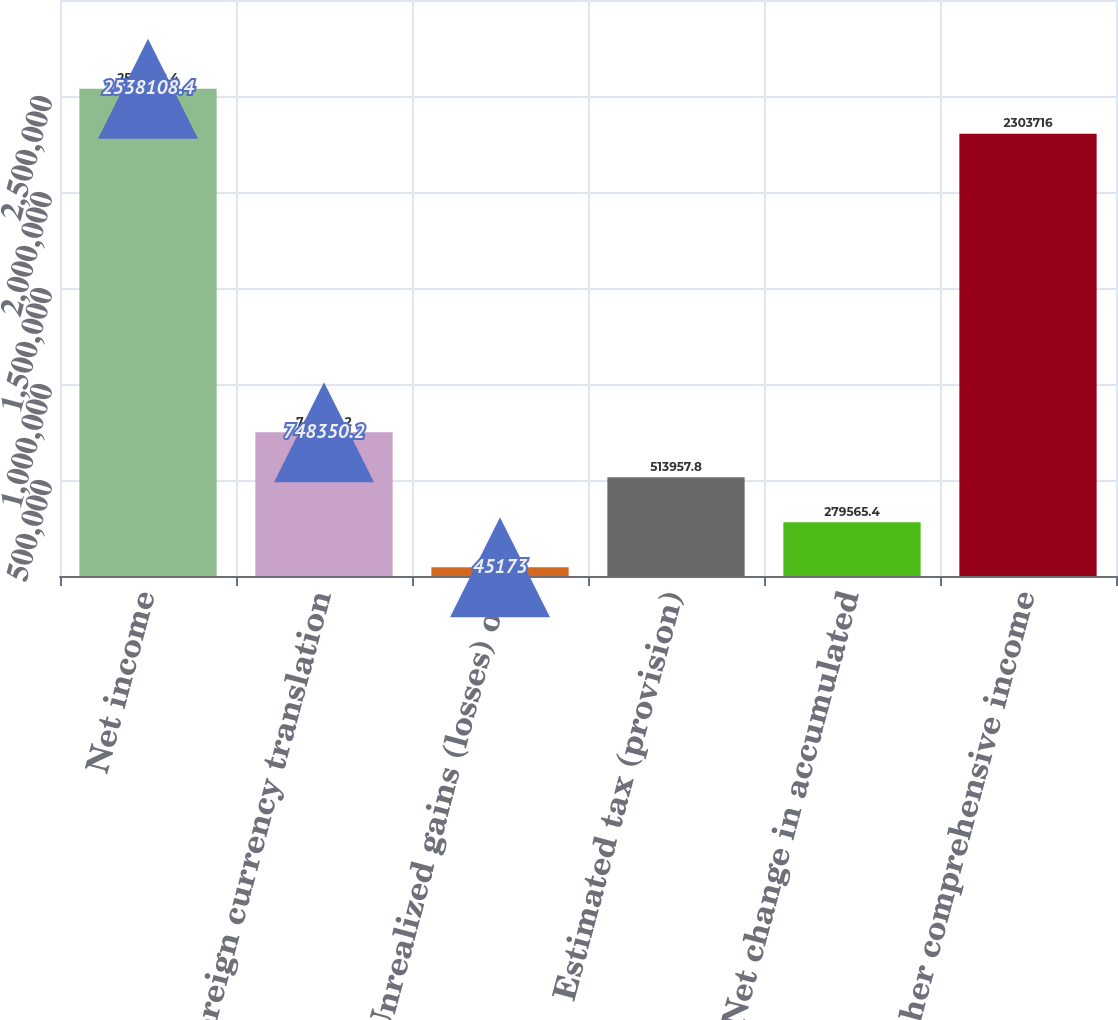Convert chart to OTSL. <chart><loc_0><loc_0><loc_500><loc_500><bar_chart><fcel>Net income<fcel>Foreign currency translation<fcel>Unrealized gains (losses) on<fcel>Estimated tax (provision)<fcel>Net change in accumulated<fcel>Other comprehensive income<nl><fcel>2.53811e+06<fcel>748350<fcel>45173<fcel>513958<fcel>279565<fcel>2.30372e+06<nl></chart> 